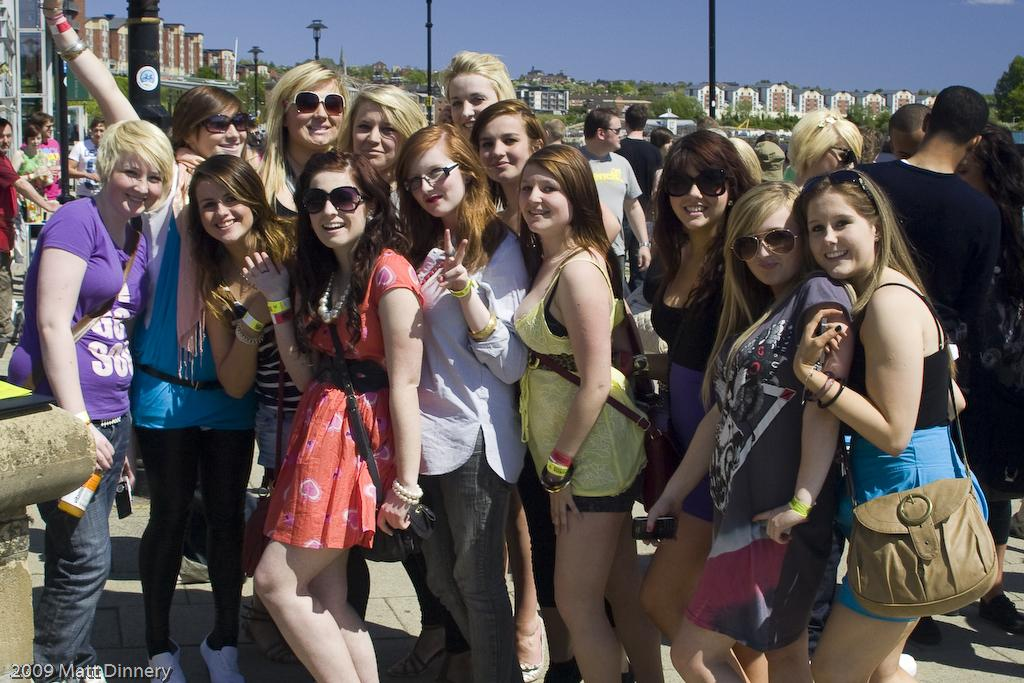How many people are present in the image? There are many people standing in the image. What can be seen in the foreground of the image? There are many poles visible in the image. What type of vegetation is behind the poles in the image? There are trees behind the poles in the image. What type of structures can be seen behind the trees in the image? There are buildings visible behind the trees in the image. What is the title of the book held by the person in the image? There is no book or person holding a book present in the image. How many eggs are visible on the ground in the image? There are no eggs visible in the image. 